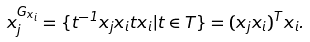Convert formula to latex. <formula><loc_0><loc_0><loc_500><loc_500>x _ { j } ^ { G _ { x _ { i } } } = \{ t ^ { - 1 } x _ { j } x _ { i } t x _ { i } | t \in T \} = ( x _ { j } x _ { i } ) ^ { T } x _ { i } .</formula> 